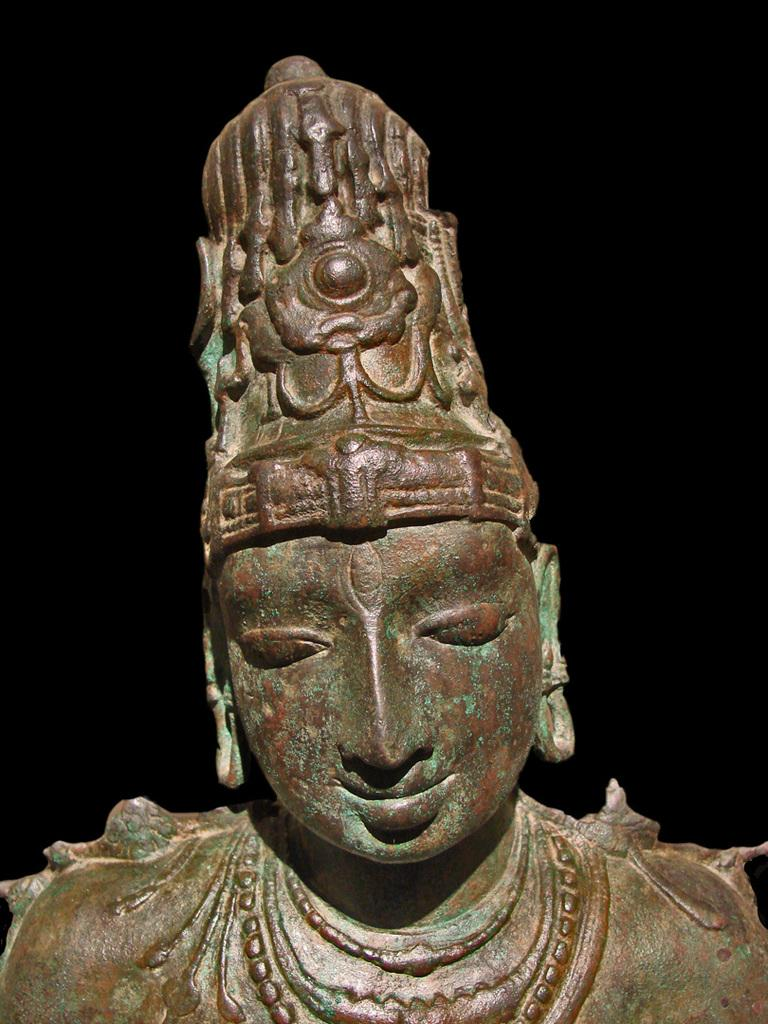What is the main subject of the image? There is a sculpture in the image. Where is the sculpture located in the image? The sculpture is in the center of the image. What color is the sculpture? The sculpture is brown in color. What type of berry can be seen growing on the sculpture in the image? There are no berries present on the sculpture in the image. What is the texture of the notebook in the image? There is no notebook present in the image. 